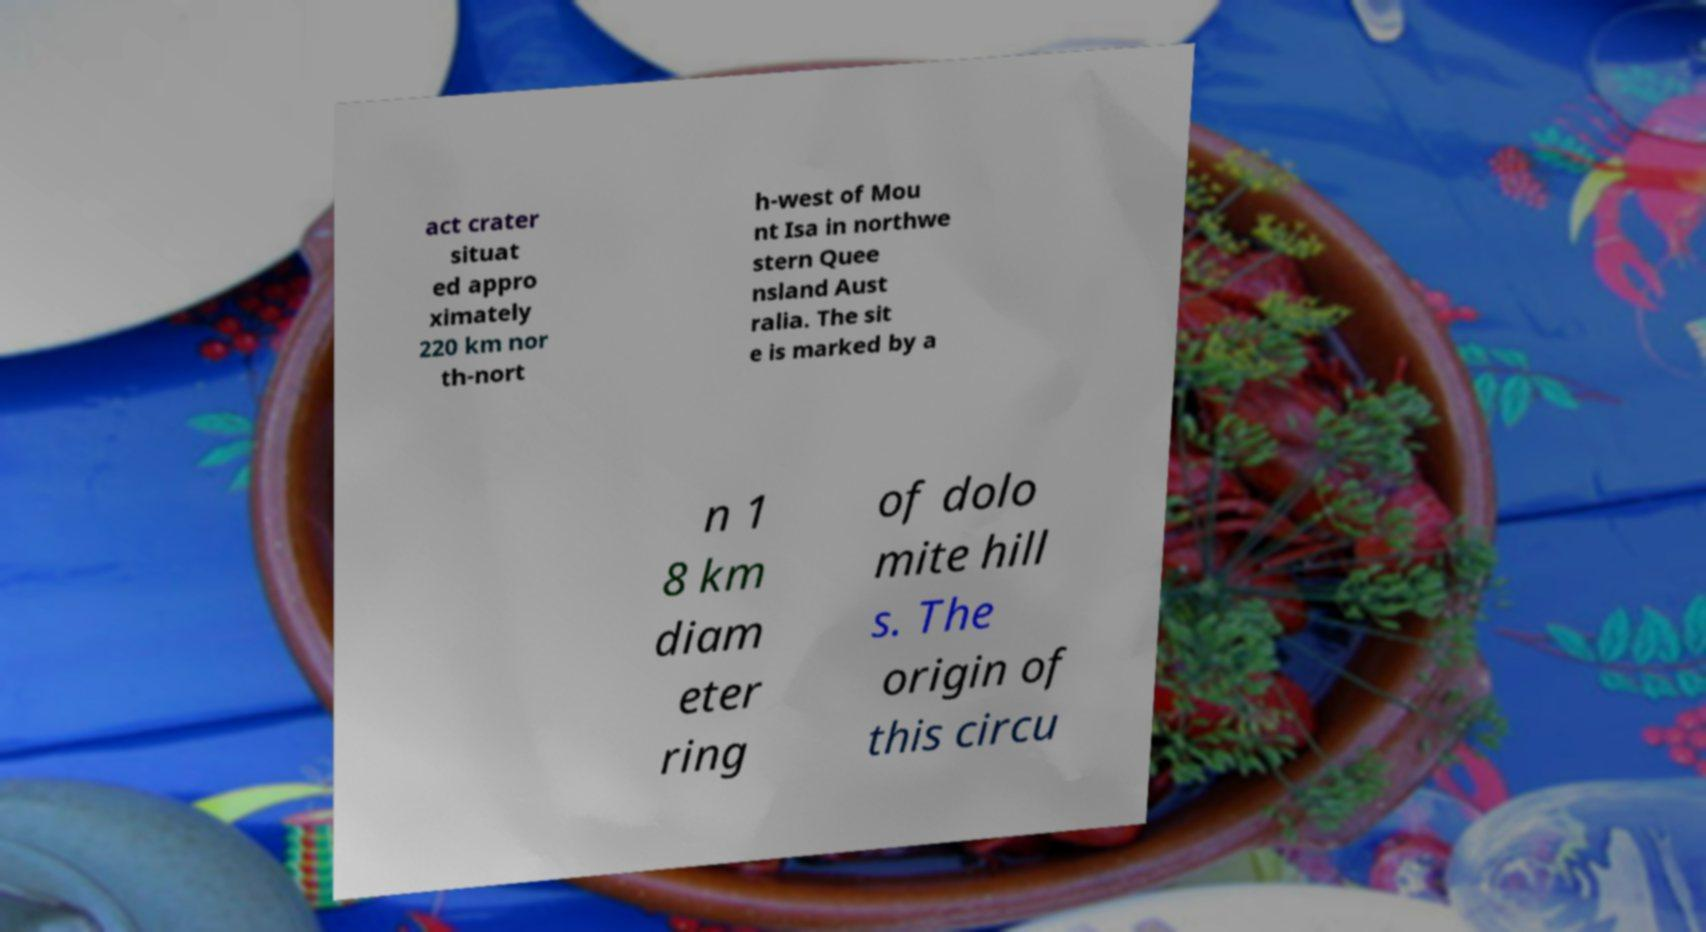Please read and relay the text visible in this image. What does it say? act crater situat ed appro ximately 220 km nor th-nort h-west of Mou nt Isa in northwe stern Quee nsland Aust ralia. The sit e is marked by a n 1 8 km diam eter ring of dolo mite hill s. The origin of this circu 